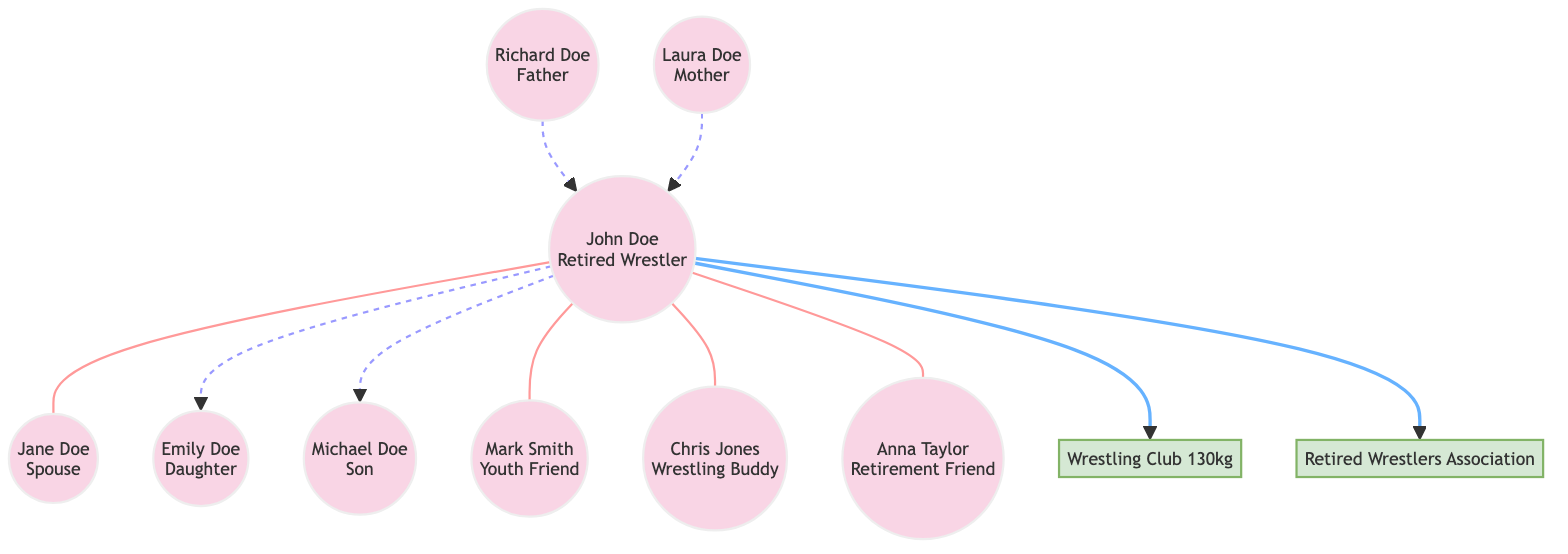What is the relationship between John Doe and Jane Doe? The diagram shows a direct edge labeled "Married to" connecting John Doe to Jane Doe. This indicates a spousal relationship between the two individuals.
Answer: Married to How many children does John Doe have? By examining the edges connected to John Doe, we see two specific relationships labeled "Father of" leading to Emily Doe and Michael Doe. Therefore, John Doe has two children.
Answer: 2 Who is John's friend from the wrestling community? The diagram connects John Doe to Chris Jones with a labeled edge that states "Wrestling buddy." This indicates that Chris Jones is identified as John's friend from the wrestling community.
Answer: Chris Jones What type of organization is the Wrestling Club 130kg? In the diagram, the node labeled "Wrestling Club 130kg" is classified as an organization according to its type, which is indicated next to the node description.
Answer: Organization Which organization is John Doe a member of? The diagram shows two edges emanating from John Doe labeled "Member of" connecting to Wrestling Club 130kg and Retired Wrestlers Association. This indicates that John Doe is affiliated with both organizations.
Answer: Wrestling Club 130kg, Retired Wrestlers Association Who is the daughter of John Doe? The edge labeled "Father of" pointing from John Doe to Emily Doe identifies Emily Doe as John Doe's daughter.
Answer: Emily Doe How are Laura Doe and John Doe related? The edge labeled "Son of" from John Doe to Laura Doe indicates that Laura Doe is his mother, establishing a maternal relationship between them.
Answer: Mother Which node represents John's friend from youth? The edge labeled "Friends since youth" connects John Doe to Mark Smith, indicating that Mark Smith is identified as John's friend from their youthful days.
Answer: Mark Smith How many total relationships does John Doe have represented in the diagram? By counting all the edges connected to John Doe, which include spousal, parent-child, and friendships, we find a total of seven connections (two "Father of," one "Married to," three "Connection," and two "Affiliation").
Answer: 7 